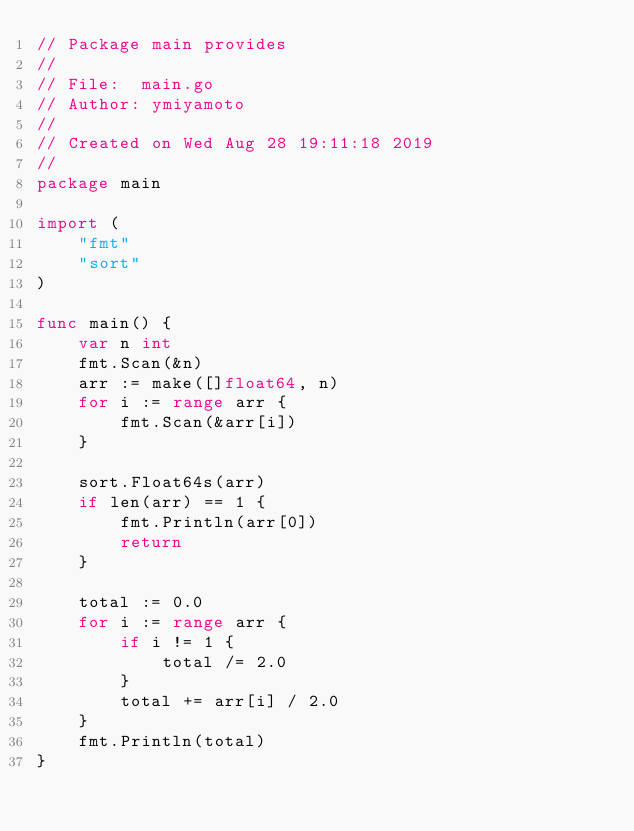Convert code to text. <code><loc_0><loc_0><loc_500><loc_500><_Go_>// Package main provides
//
// File:  main.go
// Author: ymiyamoto
//
// Created on Wed Aug 28 19:11:18 2019
//
package main

import (
	"fmt"
	"sort"
)

func main() {
	var n int
	fmt.Scan(&n)
	arr := make([]float64, n)
	for i := range arr {
		fmt.Scan(&arr[i])
	}

	sort.Float64s(arr)
	if len(arr) == 1 {
		fmt.Println(arr[0])
		return
	}

	total := 0.0
	for i := range arr {
		if i != 1 {
			total /= 2.0
		}
		total += arr[i] / 2.0
	}
	fmt.Println(total)
}
</code> 